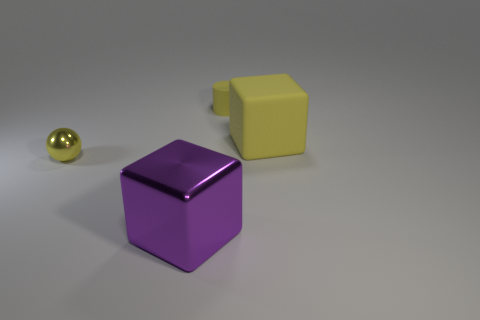There is a sphere that is the same color as the small matte object; what material is it?
Keep it short and to the point. Metal. Do the small ball and the tiny cylinder have the same color?
Your response must be concise. Yes. There is a shiny object behind the large cube in front of the shiny ball; what number of tiny objects are behind it?
Give a very brief answer. 1. What number of rubber objects are tiny yellow objects or cubes?
Make the answer very short. 2. There is a matte thing left of the cube to the right of the big purple object; what size is it?
Provide a succinct answer. Small. Do the big thing that is on the right side of the small yellow matte cylinder and the small object in front of the cylinder have the same color?
Your response must be concise. Yes. What is the color of the object that is to the left of the small matte cylinder and behind the purple thing?
Your answer should be very brief. Yellow. Is the purple cube made of the same material as the small yellow cylinder?
Your answer should be very brief. No. How many big objects are either spheres or yellow rubber objects?
Your response must be concise. 1. Is there anything else that has the same shape as the big yellow matte object?
Make the answer very short. Yes. 